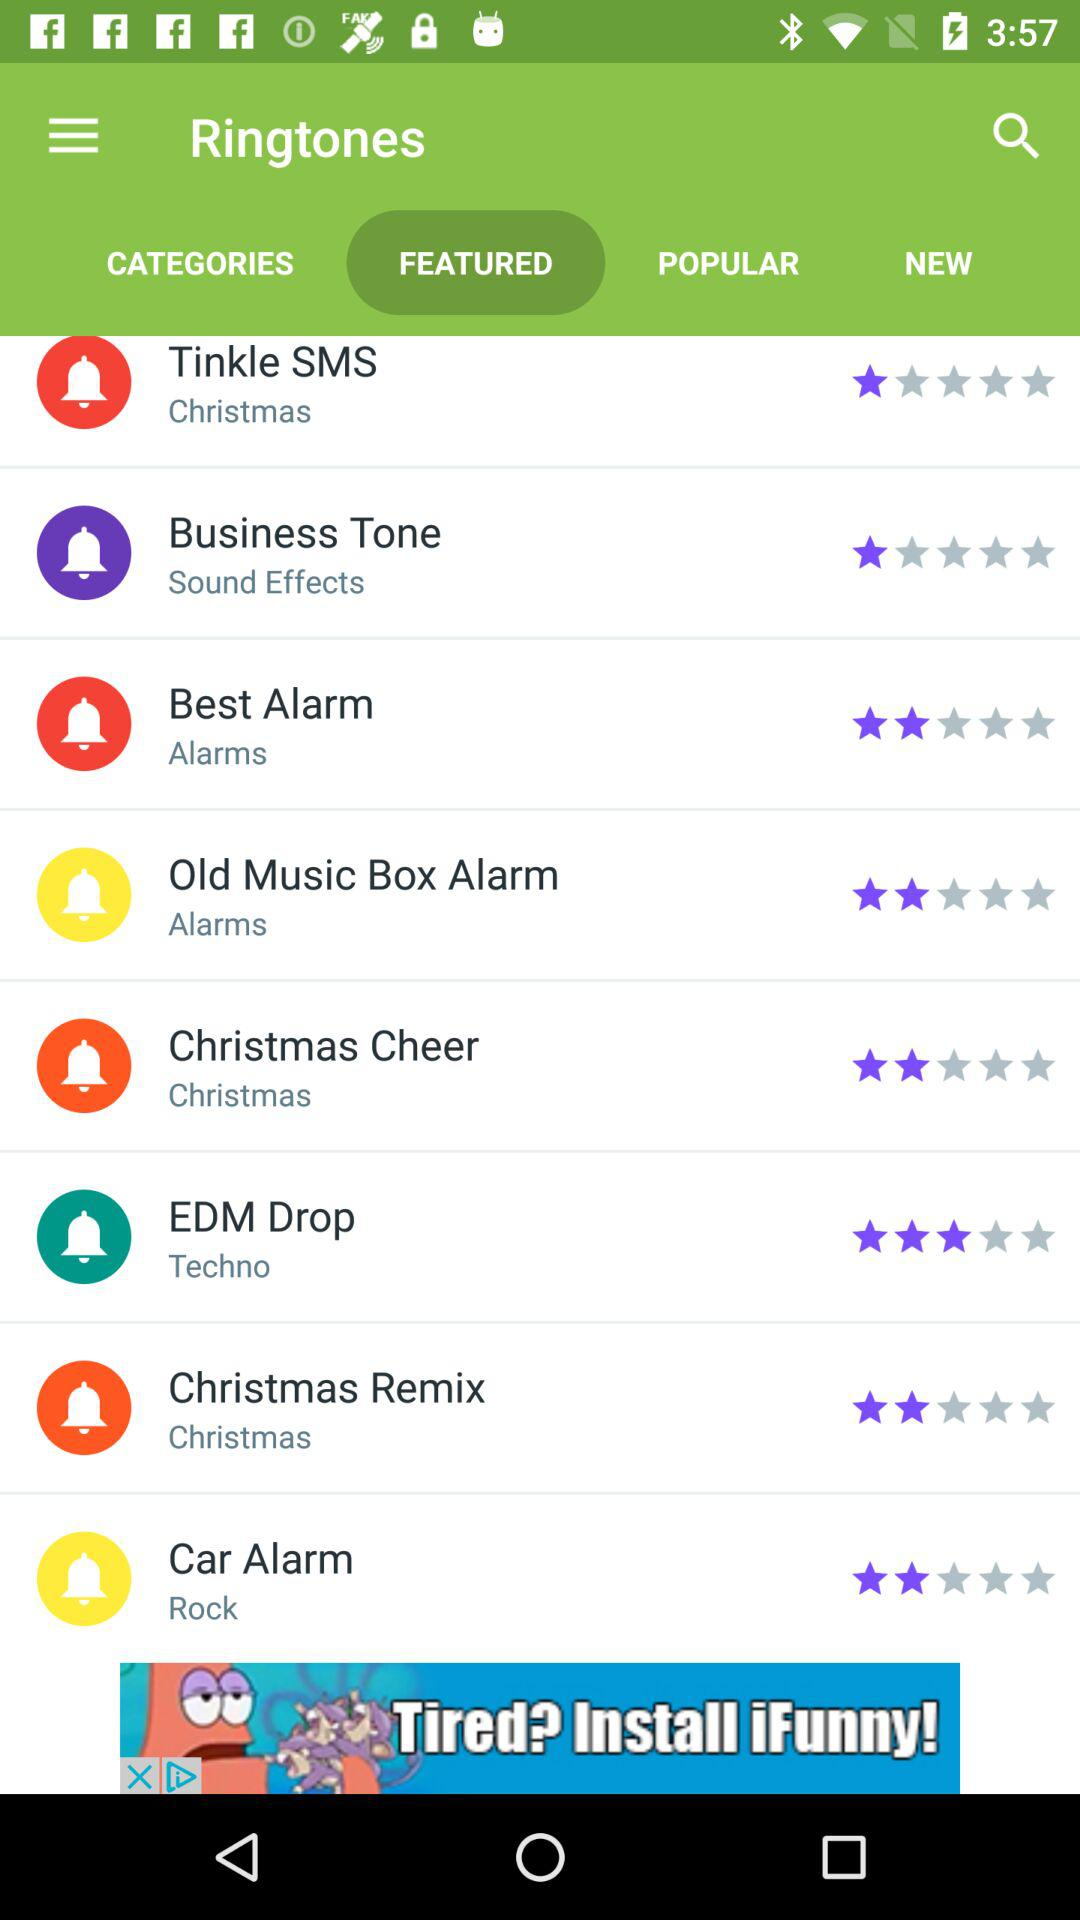Which ringtone got 3 stars out of five? The ringtone is "EDM Drop". 